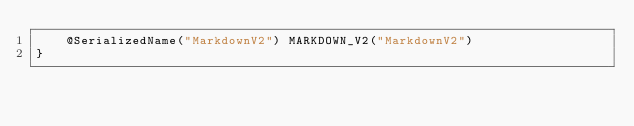<code> <loc_0><loc_0><loc_500><loc_500><_Kotlin_>    @SerializedName("MarkdownV2") MARKDOWN_V2("MarkdownV2")
}
</code> 